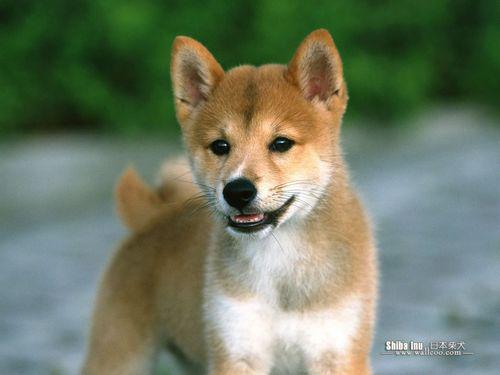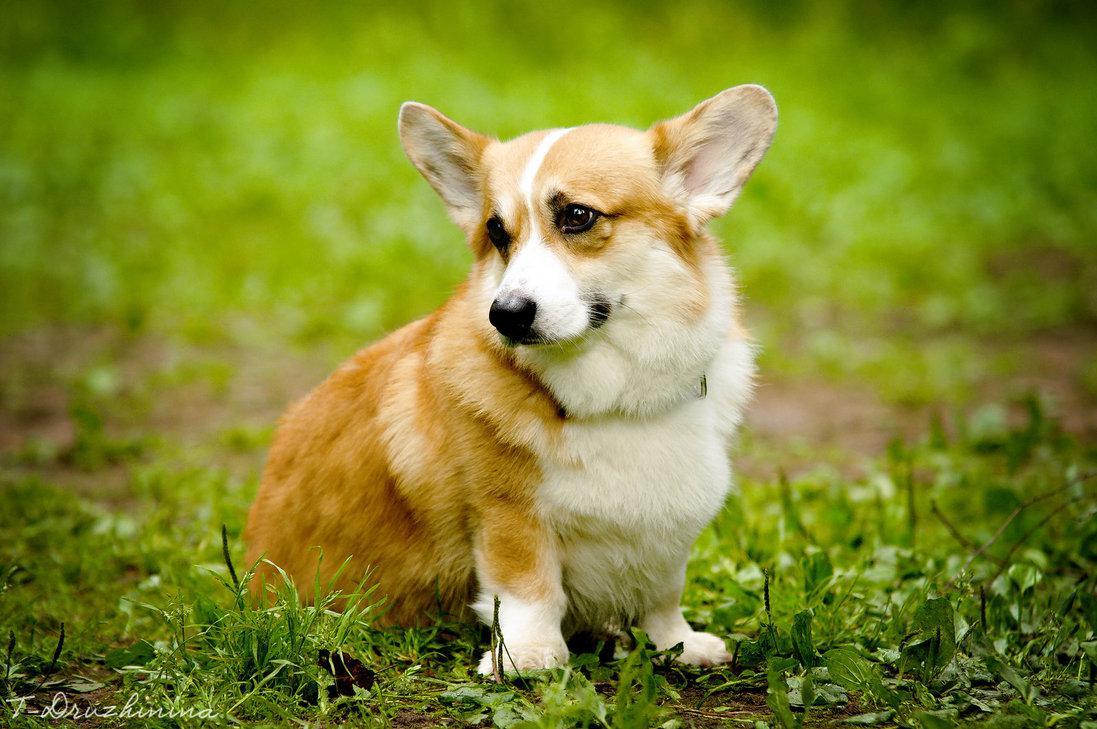The first image is the image on the left, the second image is the image on the right. Analyze the images presented: Is the assertion "One image shows a grinning, close-mouthed corgi with ears that splay outward, sitting upright in grass." valid? Answer yes or no. Yes. The first image is the image on the left, the second image is the image on the right. Given the left and right images, does the statement "There is one corgi sitting in the grass outside and another corgi who is standing in the grass while outside." hold true? Answer yes or no. No. 